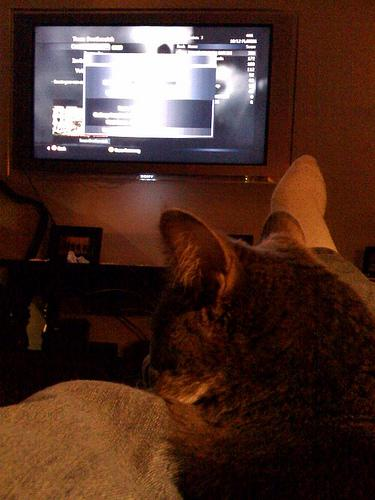Question: what animal is in the foreground of this picture?
Choices:
A. A cat.
B. A dog.
C. A sheep.
D. A goat.
Answer with the letter. Answer: A Question: how many televisions are there?
Choices:
A. 2.
B. 3.
C. 0.
D. 1.
Answer with the letter. Answer: D Question: why is the television on?
Choices:
A. A movie.
B. A television show.
C. Video games.
D. A sports game.
Answer with the letter. Answer: C 